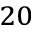<formula> <loc_0><loc_0><loc_500><loc_500>^ { 2 0 }</formula> 